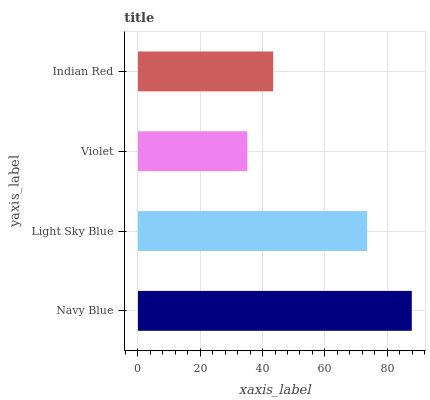Is Violet the minimum?
Answer yes or no. Yes. Is Navy Blue the maximum?
Answer yes or no. Yes. Is Light Sky Blue the minimum?
Answer yes or no. No. Is Light Sky Blue the maximum?
Answer yes or no. No. Is Navy Blue greater than Light Sky Blue?
Answer yes or no. Yes. Is Light Sky Blue less than Navy Blue?
Answer yes or no. Yes. Is Light Sky Blue greater than Navy Blue?
Answer yes or no. No. Is Navy Blue less than Light Sky Blue?
Answer yes or no. No. Is Light Sky Blue the high median?
Answer yes or no. Yes. Is Indian Red the low median?
Answer yes or no. Yes. Is Violet the high median?
Answer yes or no. No. Is Light Sky Blue the low median?
Answer yes or no. No. 